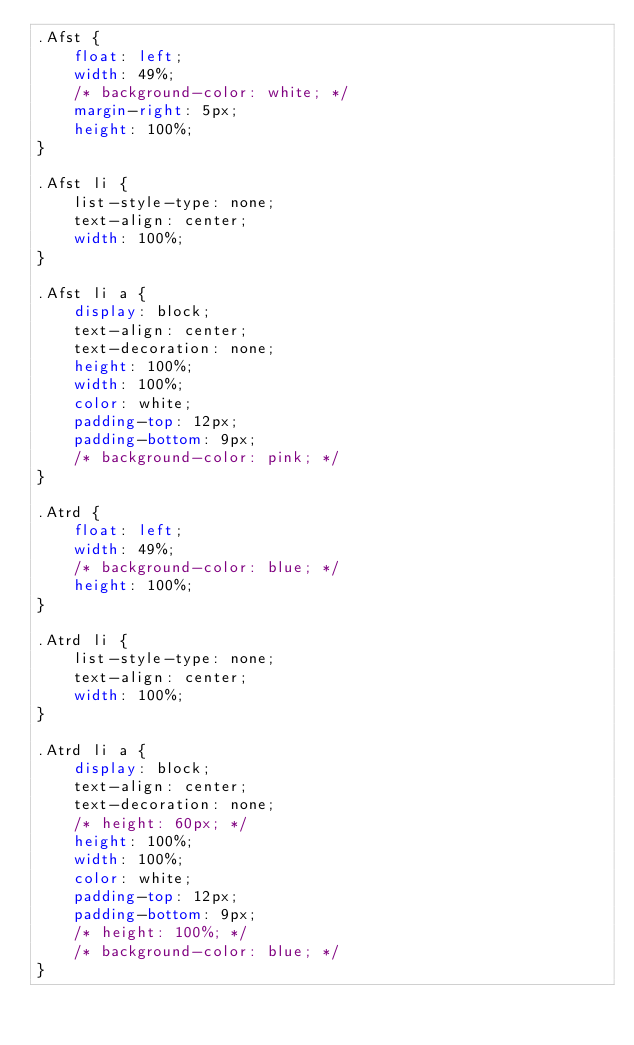<code> <loc_0><loc_0><loc_500><loc_500><_CSS_>.Afst {
    float: left;
    width: 49%;
    /* background-color: white; */
    margin-right: 5px;
    height: 100%;
}

.Afst li {
    list-style-type: none;
    text-align: center;
    width: 100%;
}

.Afst li a {
    display: block;
    text-align: center;
    text-decoration: none;
    height: 100%;
    width: 100%;
    color: white;
    padding-top: 12px;
    padding-bottom: 9px;
    /* background-color: pink; */
}

.Atrd {
    float: left;
    width: 49%;
    /* background-color: blue; */
    height: 100%;
}

.Atrd li {
    list-style-type: none;
    text-align: center;
    width: 100%;
}

.Atrd li a {
    display: block;
    text-align: center;
    text-decoration: none;
    /* height: 60px; */
    height: 100%;
    width: 100%;
    color: white;
    padding-top: 12px;
    padding-bottom: 9px;
    /* height: 100%; */
    /* background-color: blue; */
}</code> 